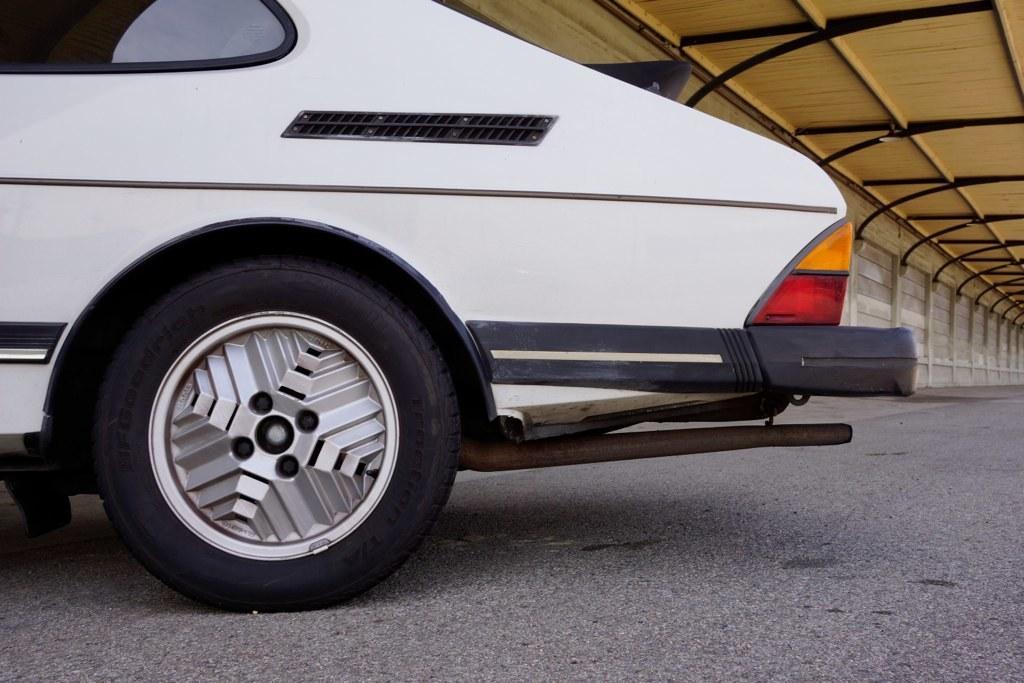In one or two sentences, can you explain what this image depicts? In the picture I can see the white color car on the road and in the background, I can see the wall and the roof. 